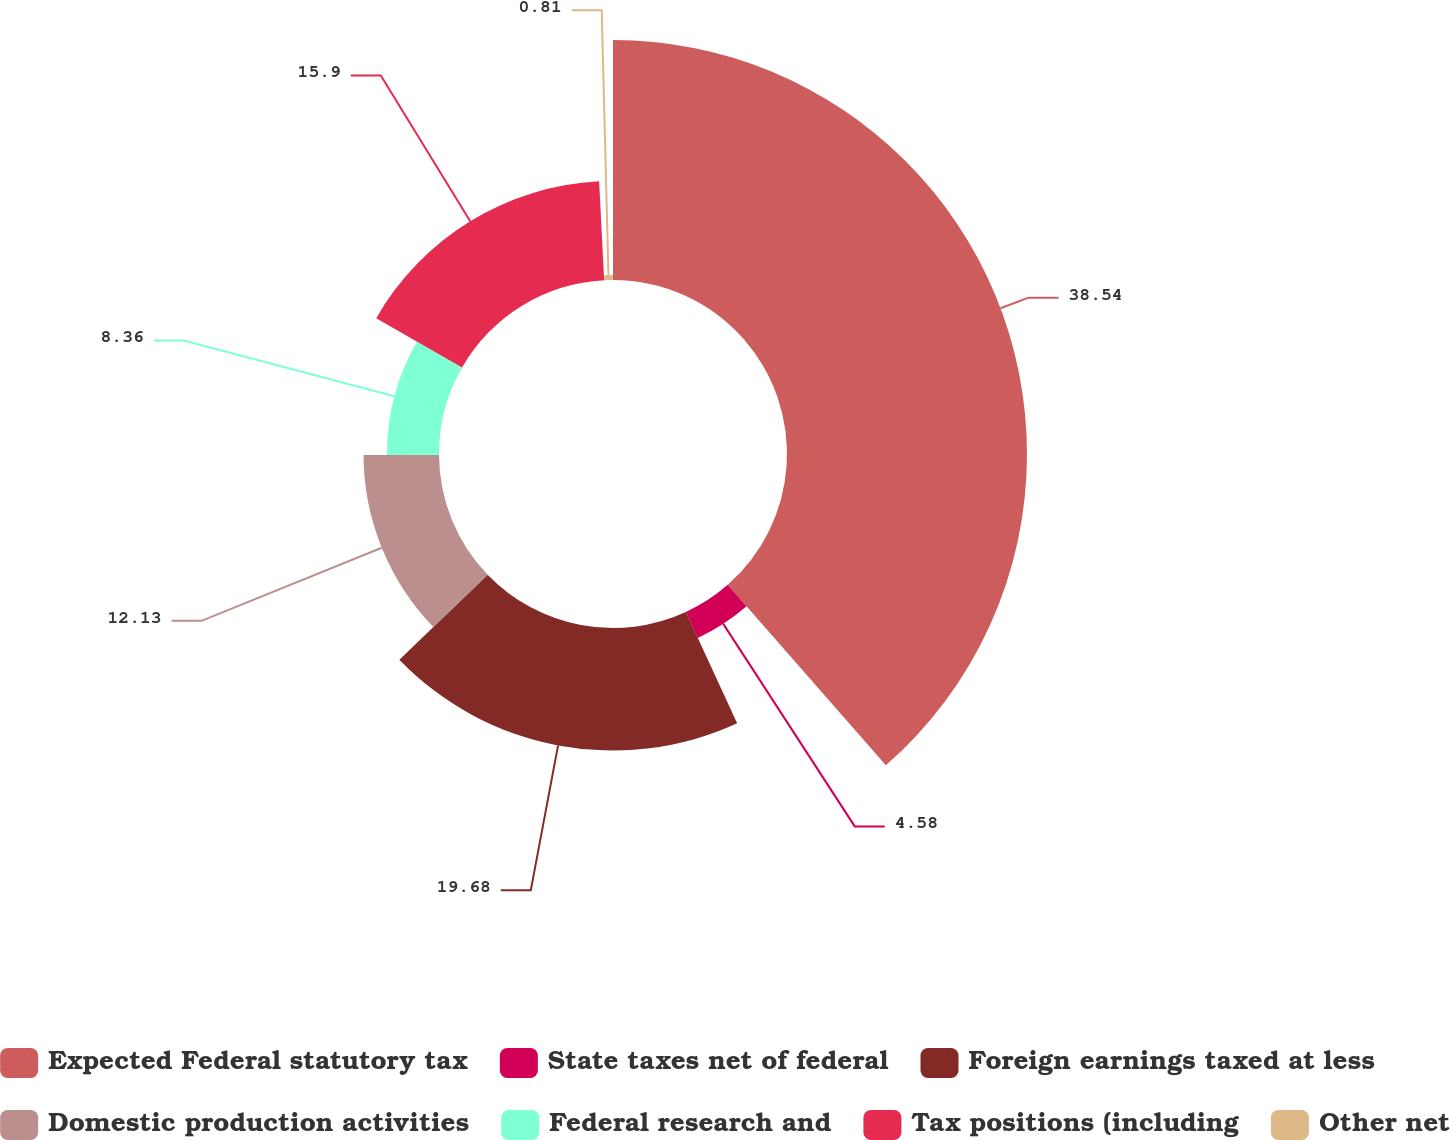Convert chart to OTSL. <chart><loc_0><loc_0><loc_500><loc_500><pie_chart><fcel>Expected Federal statutory tax<fcel>State taxes net of federal<fcel>Foreign earnings taxed at less<fcel>Domestic production activities<fcel>Federal research and<fcel>Tax positions (including<fcel>Other net<nl><fcel>38.55%<fcel>4.58%<fcel>19.68%<fcel>12.13%<fcel>8.36%<fcel>15.9%<fcel>0.81%<nl></chart> 